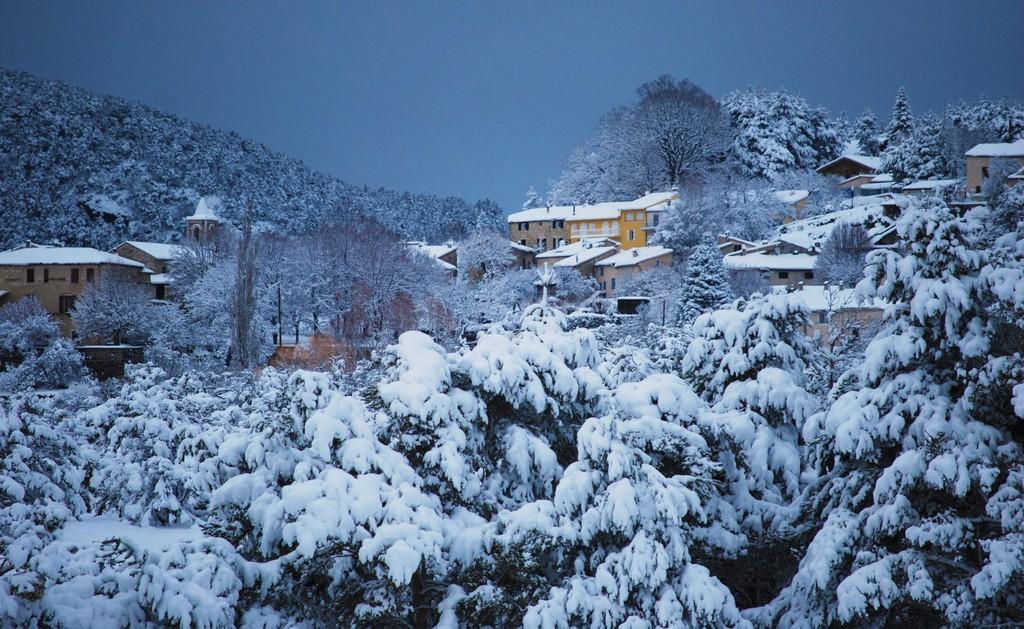What is the overall appearance of the image? The image is covered with snow. What structures can be seen on the left side of the image? There are houses on the left side of the image. What can be seen in the background of the image? The sky is visible in the background of the image. Are there any bears visible in the image? There are no bears present in the image. What type of books can be seen on the snow in the image? There are no books present in the image; it is covered with snow. 